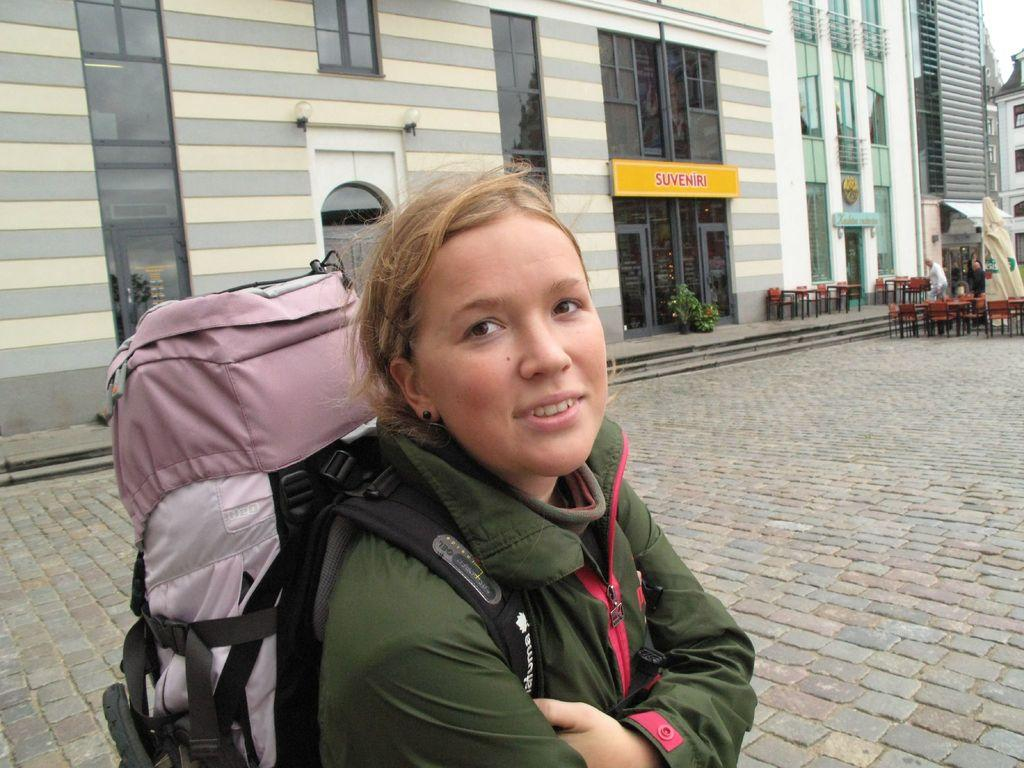<image>
Describe the image concisely. A young woman carrying a backpack who is near a store named Souveniri. 